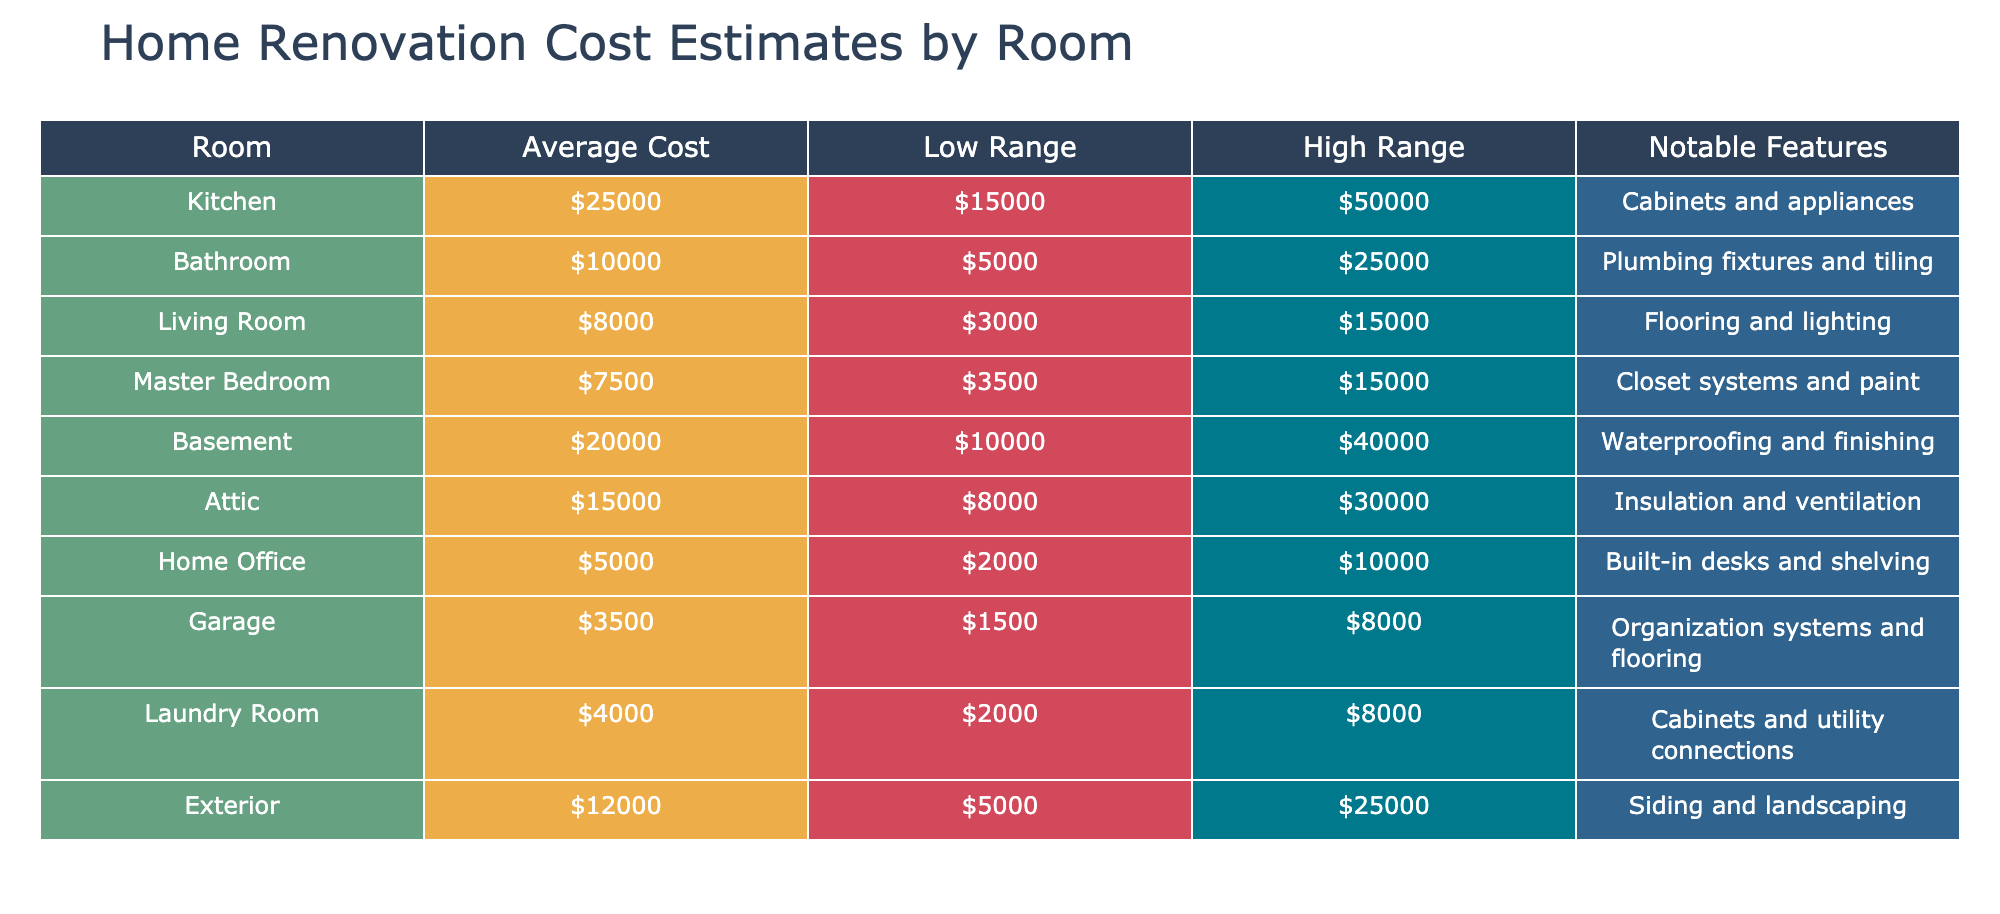What is the average cost for renovating a bathroom? The table shows that the average cost for a bathroom renovation is listed as $10,000. This can be directly retrieved from the Average Cost column corresponding to the Bathroom row.
Answer: $10,000 Which room has the highest renovation cost estimate? By examining the Average Cost column, the Kitchen has the highest value at $25,000, which is higher than any other room listed.
Answer: Kitchen What is the total renovation cost if renovating both the kitchen and bathroom? The average costs for the kitchen and bathroom are $25,000 and $10,000 respectively. Adding these together gives $25,000 + $10,000 = $35,000 for both renovations.
Answer: $35,000 Is the average cost to renovate a garage more than $4,000? The average cost to renovate a garage is $3,500, which is less than $4,000, so the statement is false.
Answer: No What is the difference in cost estimates between renovating a basement and a living room? The average cost for the basement is $20,000, and for the living room, it is $8,000. The difference is calculated by subtracting the living room cost from the basement cost: $20,000 - $8,000 = $12,000.
Answer: $12,000 Is the high range for the attic renovation estimate greater than $25,000? The high range for attic renovation is $30,000, which is indeed greater than $25,000, so the statement is true.
Answer: Yes How much can one potentially save if their budget for the laundry room is $6,000? The average cost of renovating the laundry room is $4,000. From a budget of $6,000, the potential saving can be calculated as $6,000 - $4,000 = $2,000.
Answer: $2,000 Which room has the lowest average renovation cost? The table shows that the garage has the lowest average renovation cost at $3,500, making it the least expensive room to renovate.
Answer: Garage 